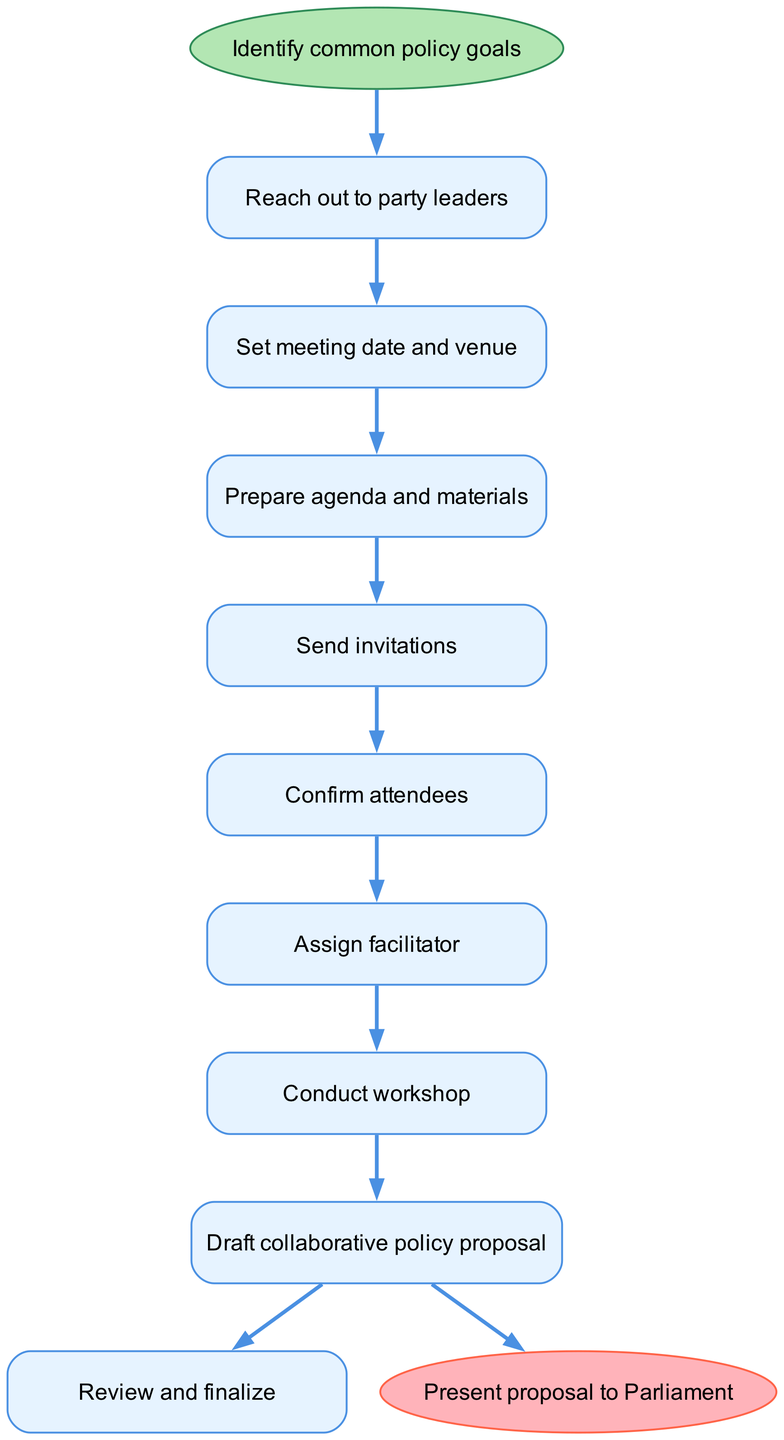What is the first step in the workshop organization process? The first step indicated in the diagram is "Identify common policy goals". This is located at the start node of the flow chart, which outlines the initial action required before continuing.
Answer: Identify common policy goals How many steps are there in total? The diagram includes a list of steps from start to end, totaling eight process nodes between the start and end points. Counting all these steps gives us eight distinct actions.
Answer: Eight What is the last node in the flow chart? The final node represented in the flow chart is "Present proposal to Parliament". This is depicted as the end point of the flow, following the last action in the sequence.
Answer: Present proposal to Parliament What comes after "Send invitations"? Following "Send invitations" in the flow of the chart is "Confirm attendees". This indicates that once invitations are dispatched, the next action is to confirm the participants who will attend the workshop.
Answer: Confirm attendees How does one proceed from "Prepare agenda and materials"? After the step "Prepare agenda and materials", the next step is "Send invitations". This indicates that once the agenda and materials are ready, the next logical action is to invite participants to the workshop.
Answer: Send invitations Which step is preceded by "Confirm attendees"? The step that comes after "Confirm attendees" is "Assign facilitator". This indicates that the process of assigning a facilitator occurs after all attendees have been confirmed for the workshop.
Answer: Assign facilitator What is the relationship between "Conduct workshop" and "Draft collaborative policy proposal"? "Conduct workshop" leads directly to "Draft collaborative policy proposal". This shows a sequential relationship where the outcome of conducting the workshop is to create a draft proposal based on the discussions held during the workshop.
Answer: Draft collaborative policy proposal What is the edge color in the diagram? The edges in the flow chart are colored in blue, specifically the shade represented by the hex color code #4A90E2. This color indicates connections between various steps in the process.
Answer: Blue 